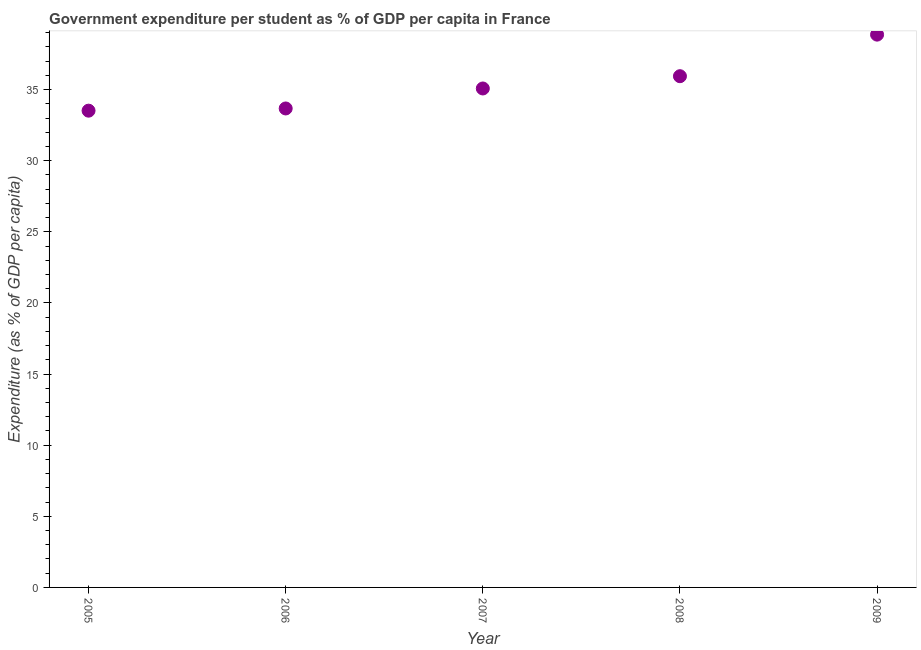What is the government expenditure per student in 2008?
Offer a very short reply. 35.94. Across all years, what is the maximum government expenditure per student?
Your response must be concise. 38.87. Across all years, what is the minimum government expenditure per student?
Offer a terse response. 33.52. What is the sum of the government expenditure per student?
Give a very brief answer. 177.08. What is the difference between the government expenditure per student in 2005 and 2008?
Offer a very short reply. -2.42. What is the average government expenditure per student per year?
Give a very brief answer. 35.42. What is the median government expenditure per student?
Make the answer very short. 35.08. What is the ratio of the government expenditure per student in 2005 to that in 2006?
Offer a very short reply. 1. Is the difference between the government expenditure per student in 2007 and 2008 greater than the difference between any two years?
Ensure brevity in your answer.  No. What is the difference between the highest and the second highest government expenditure per student?
Provide a succinct answer. 2.92. Is the sum of the government expenditure per student in 2008 and 2009 greater than the maximum government expenditure per student across all years?
Ensure brevity in your answer.  Yes. What is the difference between the highest and the lowest government expenditure per student?
Your answer should be compact. 5.35. In how many years, is the government expenditure per student greater than the average government expenditure per student taken over all years?
Offer a very short reply. 2. How many dotlines are there?
Ensure brevity in your answer.  1. Are the values on the major ticks of Y-axis written in scientific E-notation?
Your answer should be compact. No. Does the graph contain grids?
Your response must be concise. No. What is the title of the graph?
Your answer should be compact. Government expenditure per student as % of GDP per capita in France. What is the label or title of the Y-axis?
Provide a short and direct response. Expenditure (as % of GDP per capita). What is the Expenditure (as % of GDP per capita) in 2005?
Provide a short and direct response. 33.52. What is the Expenditure (as % of GDP per capita) in 2006?
Your response must be concise. 33.67. What is the Expenditure (as % of GDP per capita) in 2007?
Your answer should be very brief. 35.08. What is the Expenditure (as % of GDP per capita) in 2008?
Keep it short and to the point. 35.94. What is the Expenditure (as % of GDP per capita) in 2009?
Make the answer very short. 38.87. What is the difference between the Expenditure (as % of GDP per capita) in 2005 and 2006?
Ensure brevity in your answer.  -0.16. What is the difference between the Expenditure (as % of GDP per capita) in 2005 and 2007?
Give a very brief answer. -1.56. What is the difference between the Expenditure (as % of GDP per capita) in 2005 and 2008?
Offer a very short reply. -2.42. What is the difference between the Expenditure (as % of GDP per capita) in 2005 and 2009?
Make the answer very short. -5.35. What is the difference between the Expenditure (as % of GDP per capita) in 2006 and 2007?
Keep it short and to the point. -1.41. What is the difference between the Expenditure (as % of GDP per capita) in 2006 and 2008?
Your answer should be compact. -2.27. What is the difference between the Expenditure (as % of GDP per capita) in 2006 and 2009?
Provide a succinct answer. -5.19. What is the difference between the Expenditure (as % of GDP per capita) in 2007 and 2008?
Ensure brevity in your answer.  -0.86. What is the difference between the Expenditure (as % of GDP per capita) in 2007 and 2009?
Give a very brief answer. -3.79. What is the difference between the Expenditure (as % of GDP per capita) in 2008 and 2009?
Offer a very short reply. -2.92. What is the ratio of the Expenditure (as % of GDP per capita) in 2005 to that in 2007?
Provide a succinct answer. 0.96. What is the ratio of the Expenditure (as % of GDP per capita) in 2005 to that in 2008?
Make the answer very short. 0.93. What is the ratio of the Expenditure (as % of GDP per capita) in 2005 to that in 2009?
Your answer should be very brief. 0.86. What is the ratio of the Expenditure (as % of GDP per capita) in 2006 to that in 2008?
Offer a very short reply. 0.94. What is the ratio of the Expenditure (as % of GDP per capita) in 2006 to that in 2009?
Make the answer very short. 0.87. What is the ratio of the Expenditure (as % of GDP per capita) in 2007 to that in 2009?
Keep it short and to the point. 0.9. What is the ratio of the Expenditure (as % of GDP per capita) in 2008 to that in 2009?
Offer a very short reply. 0.93. 